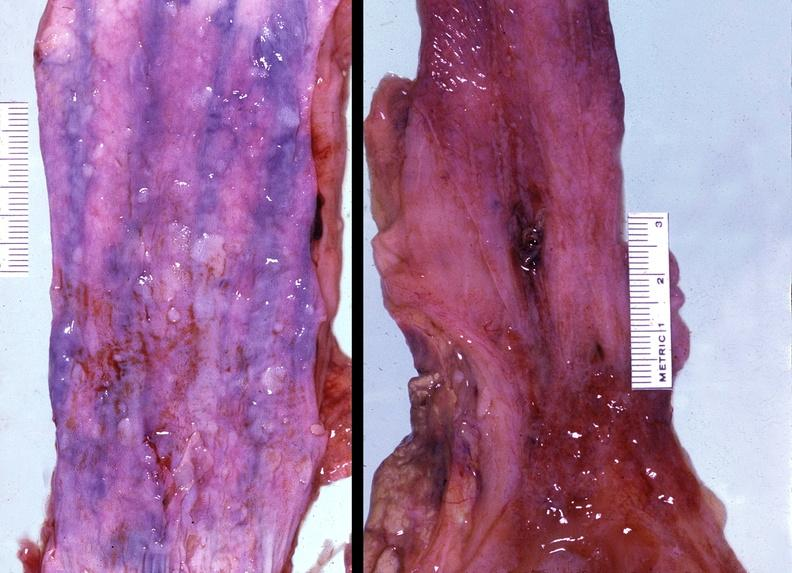s lower chest and abdomen anterior present?
Answer the question using a single word or phrase. No 